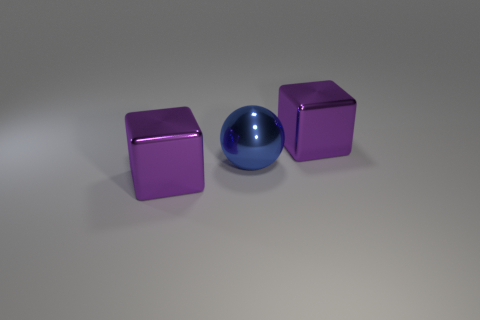Add 3 big blue balls. How many objects exist? 6 Subtract all balls. How many objects are left? 2 Subtract all purple metal cubes. Subtract all metallic spheres. How many objects are left? 0 Add 2 purple metal objects. How many purple metal objects are left? 4 Add 1 big blue spheres. How many big blue spheres exist? 2 Subtract 0 cyan cylinders. How many objects are left? 3 